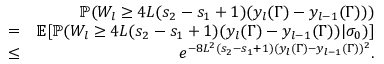<formula> <loc_0><loc_0><loc_500><loc_500>\begin{array} { r l r } & { \mathbb { P } ( W _ { l } \geq 4 L ( s _ { 2 } - s _ { 1 } + 1 ) ( y _ { l } ( \Gamma ) - y _ { l - 1 } ( \Gamma ) ) ) } \\ & { = } & { \mathbb { E } [ \mathbb { P } ( W _ { l } \geq 4 L ( s _ { 2 } - s _ { 1 } + 1 ) ( y _ { l } ( \Gamma ) - y _ { l - 1 } ( \Gamma ) ) | \sigma _ { 0 } ) ] } \\ & { \leq } & { e ^ { - 8 L ^ { 2 } ( s _ { 2 } - s _ { 1 } + 1 ) ( y _ { l } ( \Gamma ) - y _ { l - 1 } ( \Gamma ) ) ^ { 2 } } . } \end{array}</formula> 